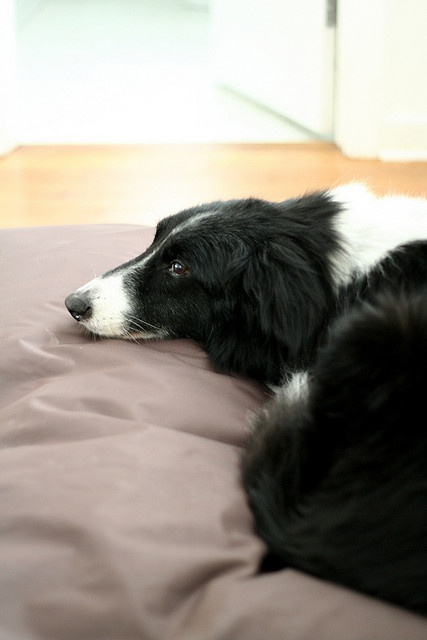Describe the objects in this image and their specific colors. I can see bed in white, darkgray, gray, and lightgray tones and dog in white, black, ivory, gray, and darkgray tones in this image. 